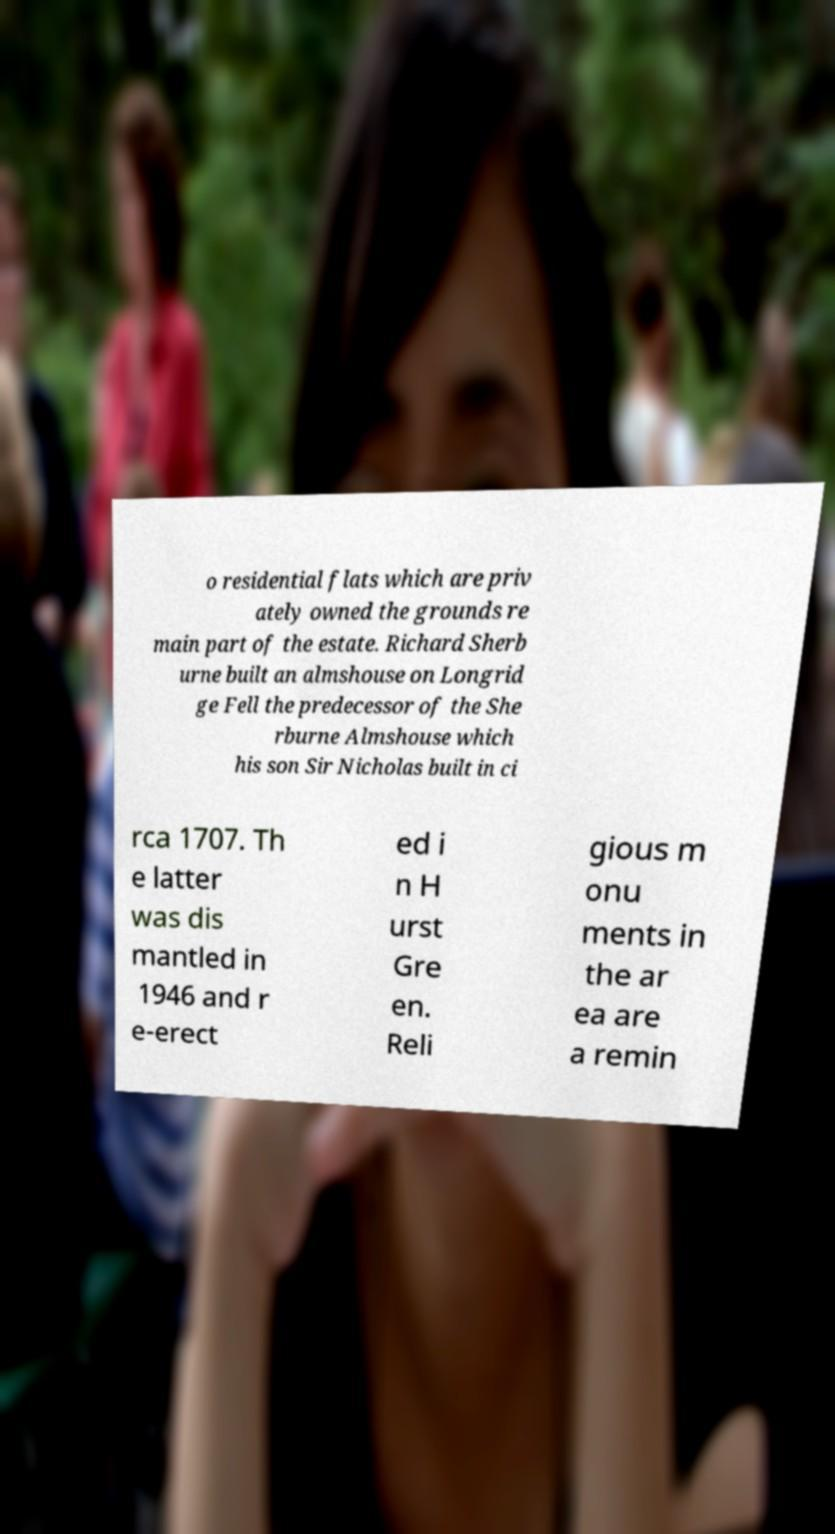Could you assist in decoding the text presented in this image and type it out clearly? o residential flats which are priv ately owned the grounds re main part of the estate. Richard Sherb urne built an almshouse on Longrid ge Fell the predecessor of the She rburne Almshouse which his son Sir Nicholas built in ci rca 1707. Th e latter was dis mantled in 1946 and r e-erect ed i n H urst Gre en. Reli gious m onu ments in the ar ea are a remin 